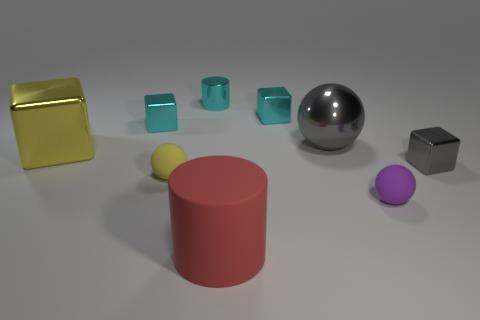What number of other things are made of the same material as the tiny yellow object?
Keep it short and to the point. 2. Are there more tiny cyan cubes that are right of the small gray metallic block than small cyan metallic blocks that are on the left side of the big red cylinder?
Give a very brief answer. No. What is the purple object in front of the big gray ball made of?
Give a very brief answer. Rubber. Do the purple object and the big red thing have the same shape?
Offer a very short reply. No. Are there any other things that are the same color as the big rubber object?
Make the answer very short. No. The other large shiny thing that is the same shape as the purple object is what color?
Provide a succinct answer. Gray. Is the number of small cyan shiny cylinders behind the small purple sphere greater than the number of purple metal blocks?
Provide a short and direct response. Yes. What is the color of the large metal object on the left side of the small cyan metal cylinder?
Your answer should be compact. Yellow. Is the yellow shiny thing the same size as the red cylinder?
Provide a succinct answer. Yes. How big is the yellow block?
Keep it short and to the point. Large. 